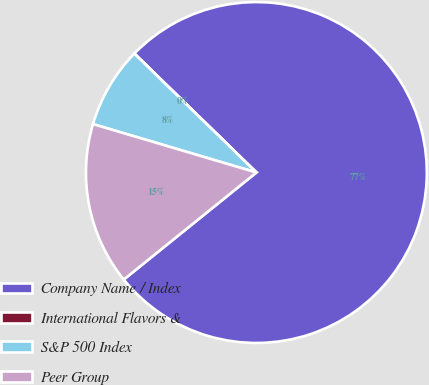Convert chart to OTSL. <chart><loc_0><loc_0><loc_500><loc_500><pie_chart><fcel>Company Name / Index<fcel>International Flavors &<fcel>S&P 500 Index<fcel>Peer Group<nl><fcel>76.89%<fcel>0.01%<fcel>7.7%<fcel>15.39%<nl></chart> 